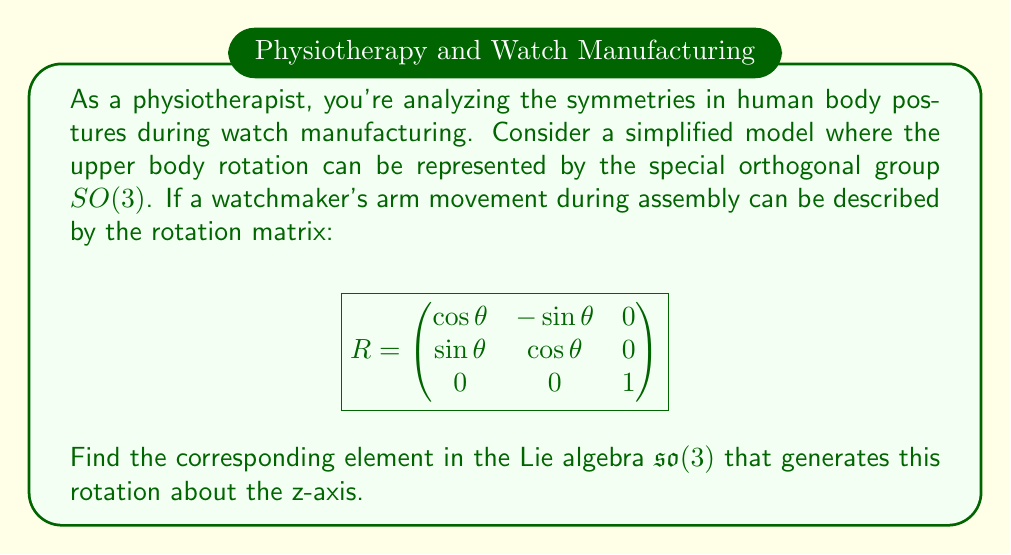Give your solution to this math problem. To solve this problem, we need to follow these steps:

1) Recall that the Lie algebra $\mathfrak{so}(3)$ consists of 3x3 skew-symmetric matrices. These matrices have the form:

   $$A = \begin{pmatrix}
   0 & -a & b \\
   a & 0 & -c \\
   -b & c & 0
   \end{pmatrix}$$

2) The relationship between a rotation matrix $R \in SO(3)$ and its corresponding Lie algebra element $A \in \mathfrak{so}(3)$ is given by the matrix exponential:

   $$R = e^A = I + A + \frac{A^2}{2!} + \frac{A^3}{3!} + \cdots$$

3) For a rotation about the z-axis, we expect the Lie algebra element to have the form:

   $$A = \begin{pmatrix}
   0 & -\alpha & 0 \\
   \alpha & 0 & 0 \\
   0 & 0 & 0
   \end{pmatrix}$$

4) To find $\alpha$, we can use the fact that for small angles, $R \approx I + A$. Comparing this with the given rotation matrix:

   $$\begin{pmatrix}
   \cos\theta & -\sin\theta & 0 \\
   \sin\theta & \cos\theta & 0 \\
   0 & 0 & 1
   \end{pmatrix} \approx \begin{pmatrix}
   1 & -\alpha & 0 \\
   \alpha & 1 & 0 \\
   0 & 0 & 1
   \end{pmatrix}$$

5) From this comparison, we can see that $\alpha = \theta$.

Therefore, the Lie algebra element that generates this rotation is:

$$A = \begin{pmatrix}
0 & -\theta & 0 \\
\theta & 0 & 0 \\
0 & 0 & 0
\end{pmatrix}$$

This element represents an infinitesimal rotation about the z-axis by angle $\theta$.
Answer: The corresponding element in the Lie algebra $\mathfrak{so}(3)$ is:

$$A = \begin{pmatrix}
0 & -\theta & 0 \\
\theta & 0 & 0 \\
0 & 0 & 0
\end{pmatrix}$$ 